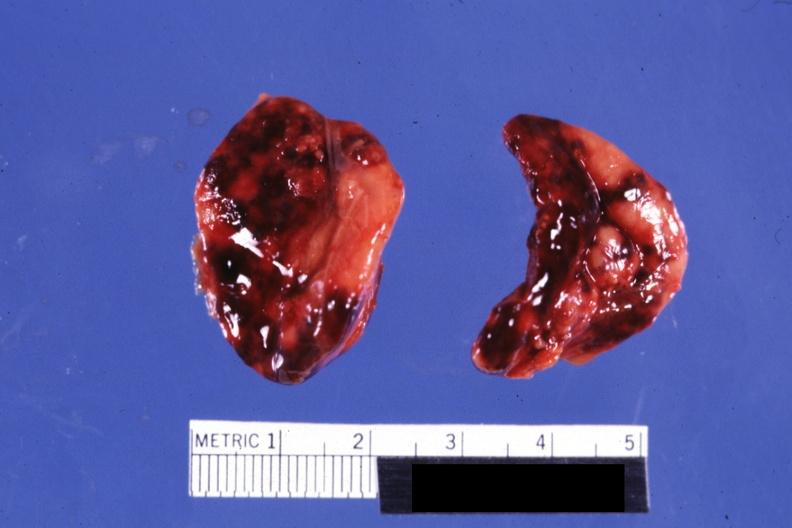what does both adrenals external views focal hemorrhages do not know history look?
Answer the question using a single word or phrase. Like placental abruption 